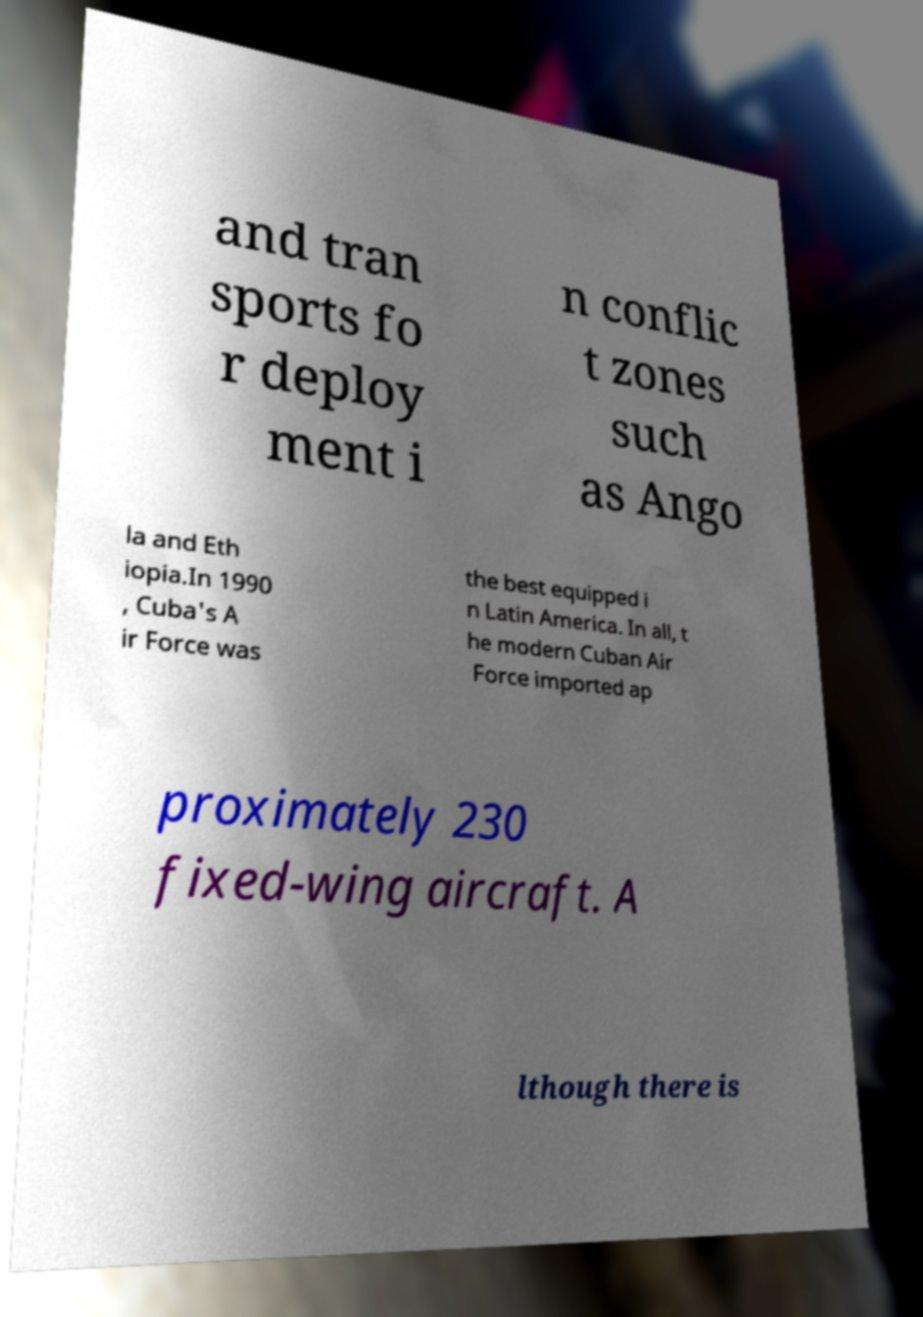For documentation purposes, I need the text within this image transcribed. Could you provide that? and tran sports fo r deploy ment i n conflic t zones such as Ango la and Eth iopia.In 1990 , Cuba's A ir Force was the best equipped i n Latin America. In all, t he modern Cuban Air Force imported ap proximately 230 fixed-wing aircraft. A lthough there is 